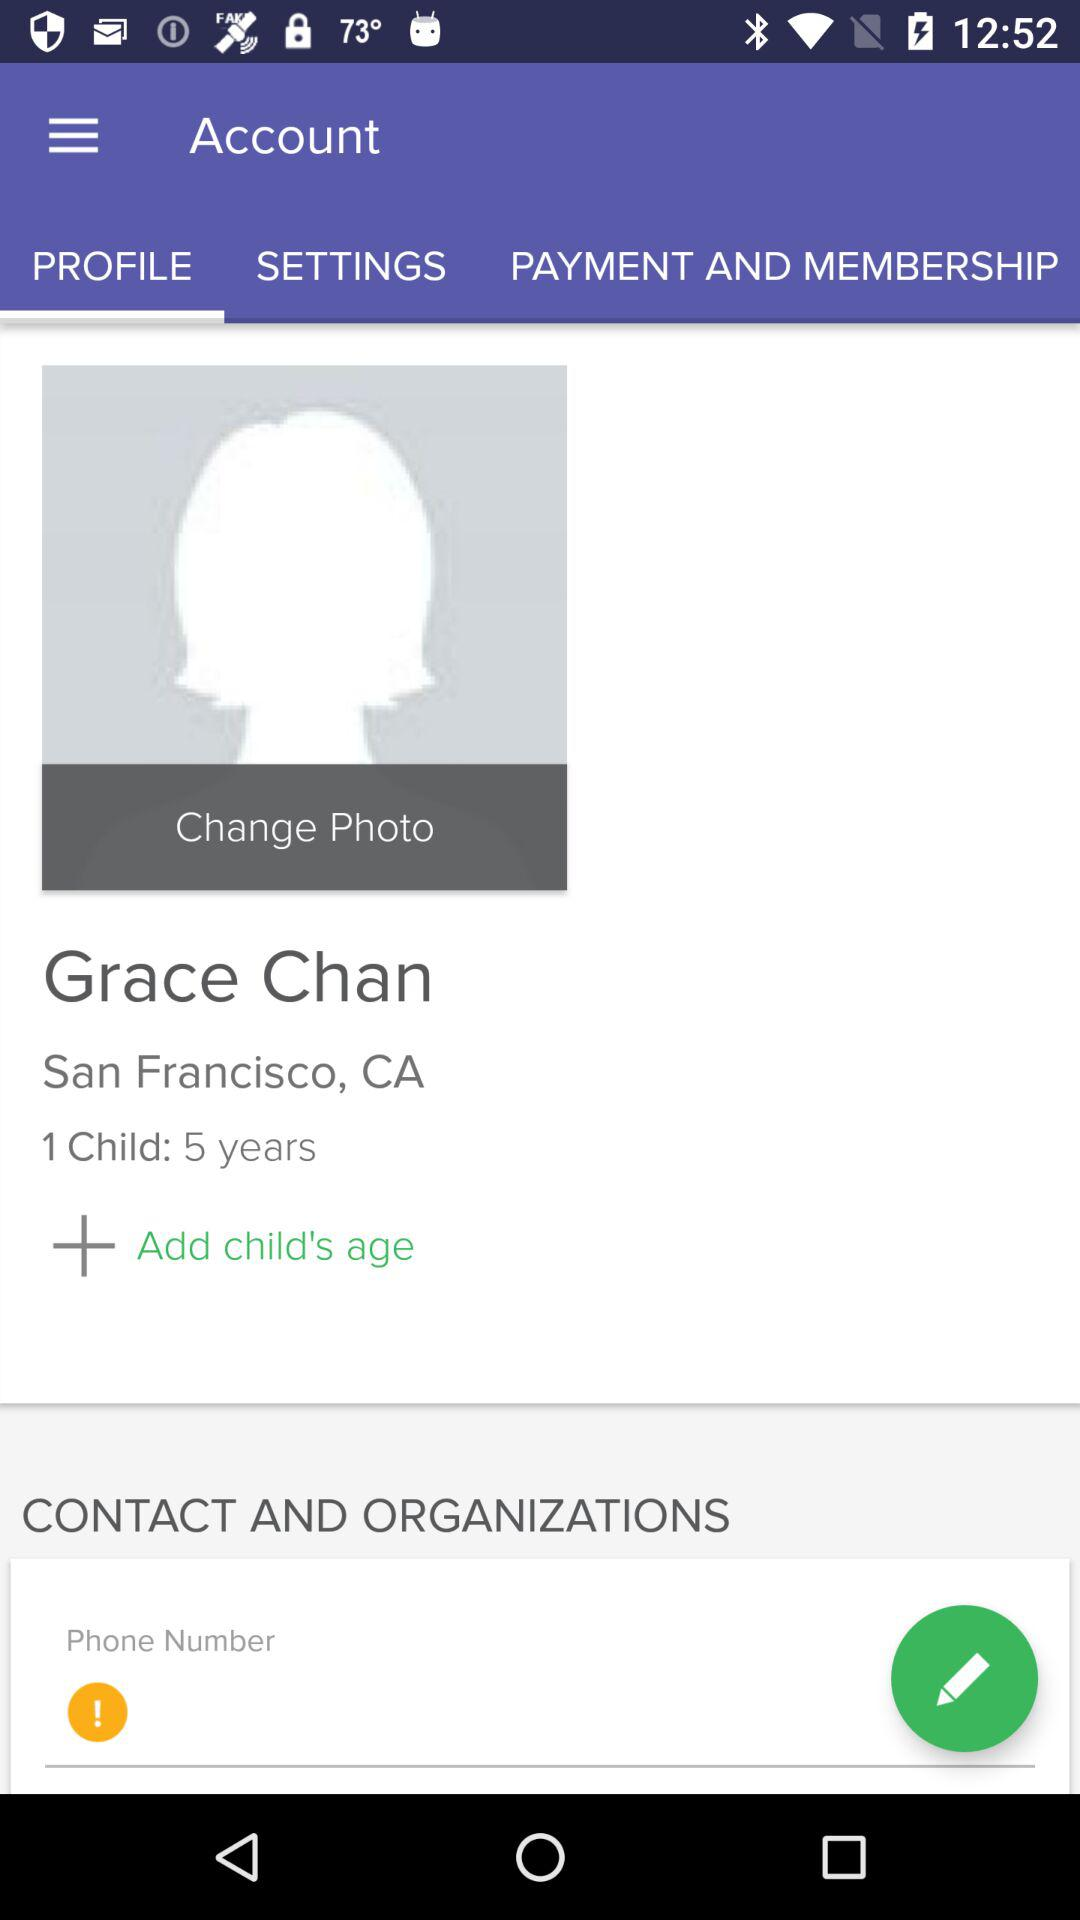What is the profile name? The profile name is Grace Chan. 